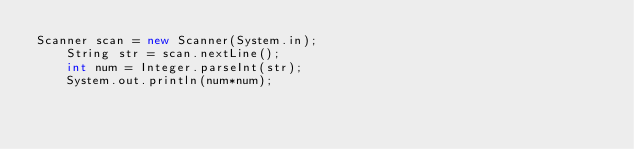<code> <loc_0><loc_0><loc_500><loc_500><_Java_>Scanner scan = new Scanner(System.in);
    String str = scan.nextLine();
    int num = Integer.parseInt(str);
    System.out.println(num*num);</code> 